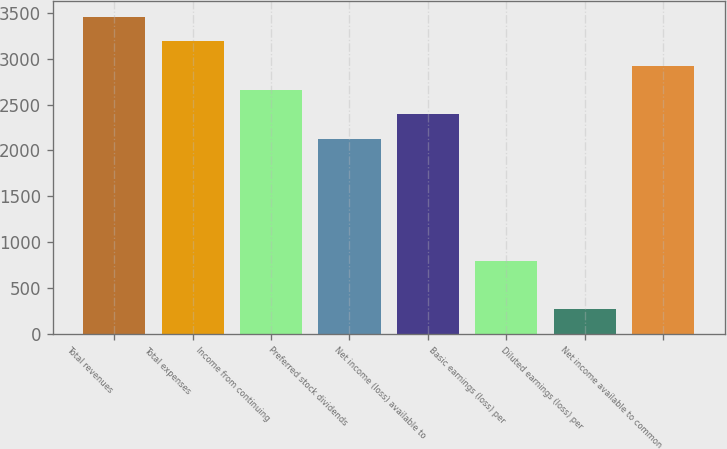Convert chart. <chart><loc_0><loc_0><loc_500><loc_500><bar_chart><fcel>Total revenues<fcel>Total expenses<fcel>Income from continuing<fcel>Preferred stock dividends<fcel>Net income (loss) available to<fcel>Basic earnings (loss) per<fcel>Diluted earnings (loss) per<fcel>Net income available to common<nl><fcel>3455.52<fcel>3189.76<fcel>2658.24<fcel>2126.72<fcel>2392.48<fcel>797.92<fcel>266.4<fcel>2924<nl></chart> 